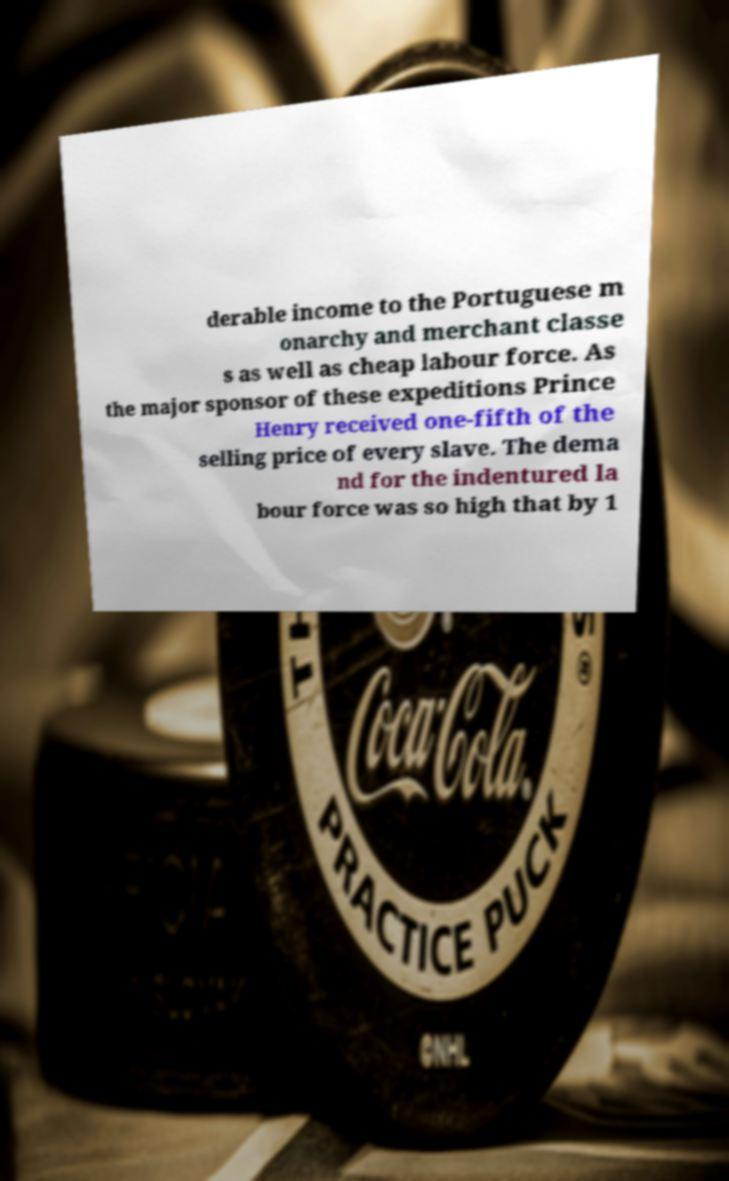Please identify and transcribe the text found in this image. derable income to the Portuguese m onarchy and merchant classe s as well as cheap labour force. As the major sponsor of these expeditions Prince Henry received one-fifth of the selling price of every slave. The dema nd for the indentured la bour force was so high that by 1 